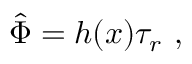<formula> <loc_0><loc_0><loc_500><loc_500>\hat { \Phi } = h ( x ) \tau _ { r } \ ,</formula> 